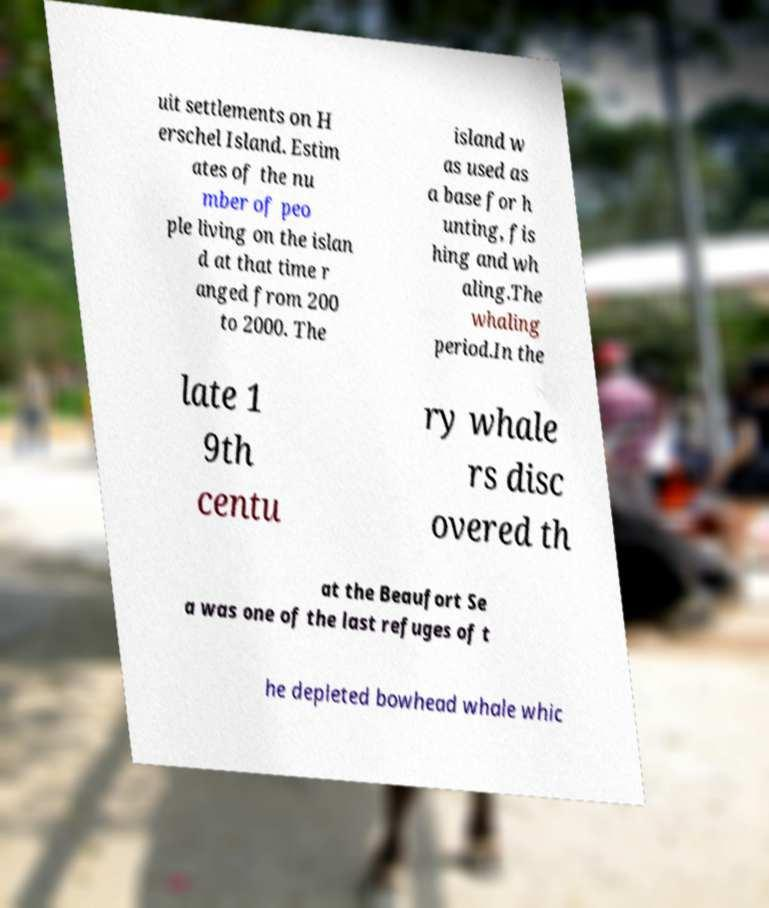Could you extract and type out the text from this image? uit settlements on H erschel Island. Estim ates of the nu mber of peo ple living on the islan d at that time r anged from 200 to 2000. The island w as used as a base for h unting, fis hing and wh aling.The whaling period.In the late 1 9th centu ry whale rs disc overed th at the Beaufort Se a was one of the last refuges of t he depleted bowhead whale whic 